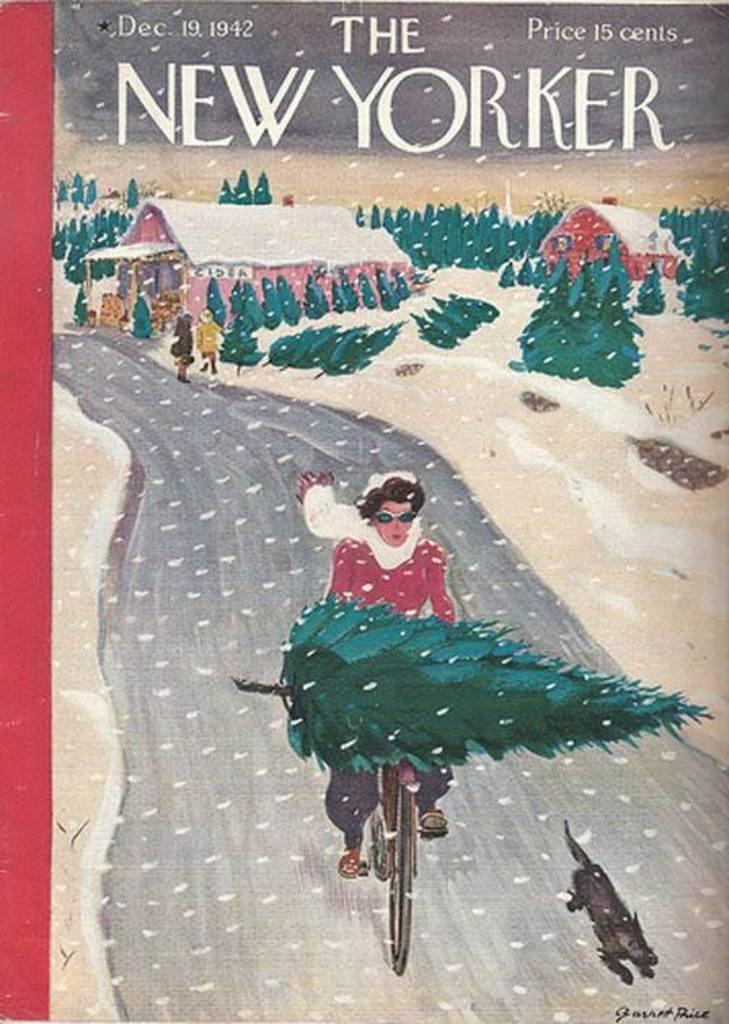How would you summarize this image in a sentence or two? In the picture I can see the poster. On the poster I can see a person riding a bicycle on the road and the person is carrying a tree on the bicycle. I can see an animal on the road on the bottom right side of the picture. In the background, I can see the houses and trees. I can see the text at the top of the picture. 